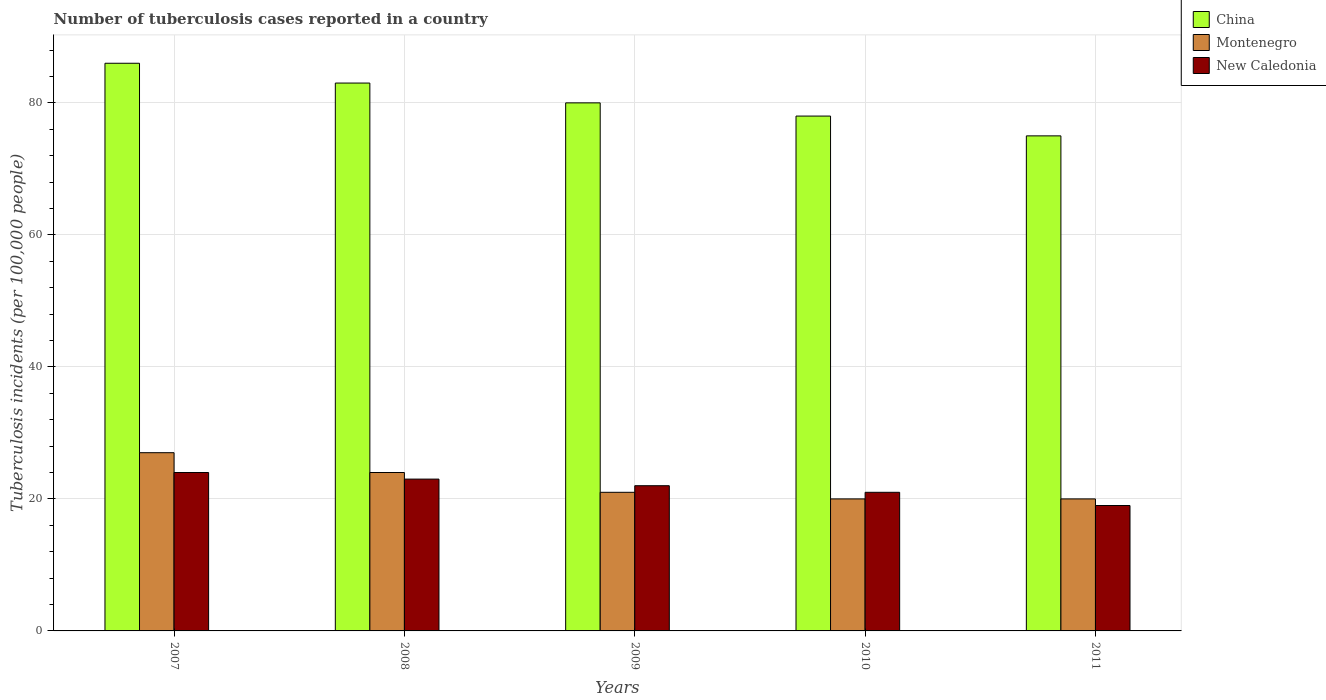How many different coloured bars are there?
Offer a terse response. 3. How many groups of bars are there?
Offer a terse response. 5. Are the number of bars per tick equal to the number of legend labels?
Keep it short and to the point. Yes. How many bars are there on the 4th tick from the left?
Your answer should be compact. 3. What is the number of tuberculosis cases reported in in China in 2007?
Your answer should be compact. 86. Across all years, what is the minimum number of tuberculosis cases reported in in New Caledonia?
Give a very brief answer. 19. In which year was the number of tuberculosis cases reported in in Montenegro maximum?
Make the answer very short. 2007. In which year was the number of tuberculosis cases reported in in New Caledonia minimum?
Offer a terse response. 2011. What is the total number of tuberculosis cases reported in in New Caledonia in the graph?
Provide a short and direct response. 109. What is the difference between the number of tuberculosis cases reported in in China in 2008 and that in 2010?
Provide a short and direct response. 5. What is the difference between the number of tuberculosis cases reported in in Montenegro in 2011 and the number of tuberculosis cases reported in in China in 2007?
Your answer should be very brief. -66. What is the average number of tuberculosis cases reported in in China per year?
Offer a very short reply. 80.4. In the year 2010, what is the difference between the number of tuberculosis cases reported in in Montenegro and number of tuberculosis cases reported in in China?
Provide a succinct answer. -58. In how many years, is the number of tuberculosis cases reported in in Montenegro greater than 60?
Ensure brevity in your answer.  0. What is the ratio of the number of tuberculosis cases reported in in Montenegro in 2007 to that in 2008?
Ensure brevity in your answer.  1.12. Is the difference between the number of tuberculosis cases reported in in Montenegro in 2009 and 2010 greater than the difference between the number of tuberculosis cases reported in in China in 2009 and 2010?
Offer a terse response. No. What is the difference between the highest and the lowest number of tuberculosis cases reported in in China?
Offer a terse response. 11. In how many years, is the number of tuberculosis cases reported in in New Caledonia greater than the average number of tuberculosis cases reported in in New Caledonia taken over all years?
Provide a succinct answer. 3. Is the sum of the number of tuberculosis cases reported in in China in 2007 and 2010 greater than the maximum number of tuberculosis cases reported in in Montenegro across all years?
Your answer should be compact. Yes. What does the 3rd bar from the left in 2009 represents?
Ensure brevity in your answer.  New Caledonia. What does the 2nd bar from the right in 2010 represents?
Offer a terse response. Montenegro. How many bars are there?
Keep it short and to the point. 15. Are all the bars in the graph horizontal?
Your answer should be compact. No. How many years are there in the graph?
Give a very brief answer. 5. Does the graph contain grids?
Give a very brief answer. Yes. What is the title of the graph?
Provide a short and direct response. Number of tuberculosis cases reported in a country. Does "Philippines" appear as one of the legend labels in the graph?
Make the answer very short. No. What is the label or title of the Y-axis?
Make the answer very short. Tuberculosis incidents (per 100,0 people). What is the Tuberculosis incidents (per 100,000 people) in China in 2007?
Keep it short and to the point. 86. What is the Tuberculosis incidents (per 100,000 people) in New Caledonia in 2007?
Keep it short and to the point. 24. What is the Tuberculosis incidents (per 100,000 people) of China in 2008?
Your response must be concise. 83. What is the Tuberculosis incidents (per 100,000 people) of Montenegro in 2008?
Provide a short and direct response. 24. What is the Tuberculosis incidents (per 100,000 people) of New Caledonia in 2008?
Make the answer very short. 23. What is the Tuberculosis incidents (per 100,000 people) in China in 2009?
Offer a very short reply. 80. What is the Tuberculosis incidents (per 100,000 people) of New Caledonia in 2010?
Provide a short and direct response. 21. What is the Tuberculosis incidents (per 100,000 people) in China in 2011?
Provide a succinct answer. 75. Across all years, what is the maximum Tuberculosis incidents (per 100,000 people) of China?
Your answer should be very brief. 86. Across all years, what is the maximum Tuberculosis incidents (per 100,000 people) of Montenegro?
Make the answer very short. 27. Across all years, what is the maximum Tuberculosis incidents (per 100,000 people) of New Caledonia?
Give a very brief answer. 24. Across all years, what is the minimum Tuberculosis incidents (per 100,000 people) of Montenegro?
Your answer should be compact. 20. Across all years, what is the minimum Tuberculosis incidents (per 100,000 people) in New Caledonia?
Make the answer very short. 19. What is the total Tuberculosis incidents (per 100,000 people) in China in the graph?
Give a very brief answer. 402. What is the total Tuberculosis incidents (per 100,000 people) in Montenegro in the graph?
Your response must be concise. 112. What is the total Tuberculosis incidents (per 100,000 people) in New Caledonia in the graph?
Your response must be concise. 109. What is the difference between the Tuberculosis incidents (per 100,000 people) in New Caledonia in 2007 and that in 2009?
Your response must be concise. 2. What is the difference between the Tuberculosis incidents (per 100,000 people) of China in 2007 and that in 2010?
Provide a short and direct response. 8. What is the difference between the Tuberculosis incidents (per 100,000 people) in Montenegro in 2007 and that in 2010?
Offer a very short reply. 7. What is the difference between the Tuberculosis incidents (per 100,000 people) of New Caledonia in 2007 and that in 2010?
Your answer should be compact. 3. What is the difference between the Tuberculosis incidents (per 100,000 people) of Montenegro in 2007 and that in 2011?
Your answer should be very brief. 7. What is the difference between the Tuberculosis incidents (per 100,000 people) of New Caledonia in 2007 and that in 2011?
Give a very brief answer. 5. What is the difference between the Tuberculosis incidents (per 100,000 people) of Montenegro in 2008 and that in 2009?
Ensure brevity in your answer.  3. What is the difference between the Tuberculosis incidents (per 100,000 people) of New Caledonia in 2008 and that in 2009?
Your answer should be very brief. 1. What is the difference between the Tuberculosis incidents (per 100,000 people) in New Caledonia in 2008 and that in 2010?
Give a very brief answer. 2. What is the difference between the Tuberculosis incidents (per 100,000 people) of China in 2008 and that in 2011?
Offer a terse response. 8. What is the difference between the Tuberculosis incidents (per 100,000 people) of Montenegro in 2008 and that in 2011?
Give a very brief answer. 4. What is the difference between the Tuberculosis incidents (per 100,000 people) of New Caledonia in 2008 and that in 2011?
Offer a very short reply. 4. What is the difference between the Tuberculosis incidents (per 100,000 people) of New Caledonia in 2009 and that in 2010?
Offer a terse response. 1. What is the difference between the Tuberculosis incidents (per 100,000 people) of Montenegro in 2010 and that in 2011?
Your answer should be compact. 0. What is the difference between the Tuberculosis incidents (per 100,000 people) in China in 2007 and the Tuberculosis incidents (per 100,000 people) in Montenegro in 2008?
Offer a terse response. 62. What is the difference between the Tuberculosis incidents (per 100,000 people) of Montenegro in 2007 and the Tuberculosis incidents (per 100,000 people) of New Caledonia in 2008?
Your answer should be very brief. 4. What is the difference between the Tuberculosis incidents (per 100,000 people) in China in 2007 and the Tuberculosis incidents (per 100,000 people) in Montenegro in 2009?
Make the answer very short. 65. What is the difference between the Tuberculosis incidents (per 100,000 people) in China in 2007 and the Tuberculosis incidents (per 100,000 people) in New Caledonia in 2009?
Provide a succinct answer. 64. What is the difference between the Tuberculosis incidents (per 100,000 people) of China in 2007 and the Tuberculosis incidents (per 100,000 people) of New Caledonia in 2010?
Make the answer very short. 65. What is the difference between the Tuberculosis incidents (per 100,000 people) of China in 2008 and the Tuberculosis incidents (per 100,000 people) of New Caledonia in 2009?
Make the answer very short. 61. What is the difference between the Tuberculosis incidents (per 100,000 people) of Montenegro in 2008 and the Tuberculosis incidents (per 100,000 people) of New Caledonia in 2009?
Provide a short and direct response. 2. What is the difference between the Tuberculosis incidents (per 100,000 people) in China in 2008 and the Tuberculosis incidents (per 100,000 people) in Montenegro in 2010?
Your response must be concise. 63. What is the difference between the Tuberculosis incidents (per 100,000 people) in China in 2009 and the Tuberculosis incidents (per 100,000 people) in Montenegro in 2010?
Offer a terse response. 60. What is the difference between the Tuberculosis incidents (per 100,000 people) in China in 2009 and the Tuberculosis incidents (per 100,000 people) in New Caledonia in 2010?
Your answer should be very brief. 59. What is the difference between the Tuberculosis incidents (per 100,000 people) of China in 2010 and the Tuberculosis incidents (per 100,000 people) of Montenegro in 2011?
Give a very brief answer. 58. What is the difference between the Tuberculosis incidents (per 100,000 people) of China in 2010 and the Tuberculosis incidents (per 100,000 people) of New Caledonia in 2011?
Your answer should be very brief. 59. What is the difference between the Tuberculosis incidents (per 100,000 people) of Montenegro in 2010 and the Tuberculosis incidents (per 100,000 people) of New Caledonia in 2011?
Ensure brevity in your answer.  1. What is the average Tuberculosis incidents (per 100,000 people) of China per year?
Provide a succinct answer. 80.4. What is the average Tuberculosis incidents (per 100,000 people) in Montenegro per year?
Provide a short and direct response. 22.4. What is the average Tuberculosis incidents (per 100,000 people) of New Caledonia per year?
Your response must be concise. 21.8. In the year 2007, what is the difference between the Tuberculosis incidents (per 100,000 people) in China and Tuberculosis incidents (per 100,000 people) in Montenegro?
Provide a short and direct response. 59. In the year 2007, what is the difference between the Tuberculosis incidents (per 100,000 people) in Montenegro and Tuberculosis incidents (per 100,000 people) in New Caledonia?
Offer a very short reply. 3. In the year 2008, what is the difference between the Tuberculosis incidents (per 100,000 people) in China and Tuberculosis incidents (per 100,000 people) in Montenegro?
Offer a very short reply. 59. In the year 2008, what is the difference between the Tuberculosis incidents (per 100,000 people) in China and Tuberculosis incidents (per 100,000 people) in New Caledonia?
Give a very brief answer. 60. In the year 2009, what is the difference between the Tuberculosis incidents (per 100,000 people) in China and Tuberculosis incidents (per 100,000 people) in Montenegro?
Offer a very short reply. 59. In the year 2010, what is the difference between the Tuberculosis incidents (per 100,000 people) in China and Tuberculosis incidents (per 100,000 people) in New Caledonia?
Make the answer very short. 57. In the year 2010, what is the difference between the Tuberculosis incidents (per 100,000 people) of Montenegro and Tuberculosis incidents (per 100,000 people) of New Caledonia?
Your response must be concise. -1. In the year 2011, what is the difference between the Tuberculosis incidents (per 100,000 people) of China and Tuberculosis incidents (per 100,000 people) of Montenegro?
Provide a short and direct response. 55. In the year 2011, what is the difference between the Tuberculosis incidents (per 100,000 people) in China and Tuberculosis incidents (per 100,000 people) in New Caledonia?
Offer a very short reply. 56. In the year 2011, what is the difference between the Tuberculosis incidents (per 100,000 people) in Montenegro and Tuberculosis incidents (per 100,000 people) in New Caledonia?
Provide a short and direct response. 1. What is the ratio of the Tuberculosis incidents (per 100,000 people) of China in 2007 to that in 2008?
Ensure brevity in your answer.  1.04. What is the ratio of the Tuberculosis incidents (per 100,000 people) in Montenegro in 2007 to that in 2008?
Offer a terse response. 1.12. What is the ratio of the Tuberculosis incidents (per 100,000 people) in New Caledonia in 2007 to that in 2008?
Provide a short and direct response. 1.04. What is the ratio of the Tuberculosis incidents (per 100,000 people) in China in 2007 to that in 2009?
Provide a short and direct response. 1.07. What is the ratio of the Tuberculosis incidents (per 100,000 people) in China in 2007 to that in 2010?
Your answer should be very brief. 1.1. What is the ratio of the Tuberculosis incidents (per 100,000 people) of Montenegro in 2007 to that in 2010?
Your response must be concise. 1.35. What is the ratio of the Tuberculosis incidents (per 100,000 people) of China in 2007 to that in 2011?
Make the answer very short. 1.15. What is the ratio of the Tuberculosis incidents (per 100,000 people) in Montenegro in 2007 to that in 2011?
Ensure brevity in your answer.  1.35. What is the ratio of the Tuberculosis incidents (per 100,000 people) of New Caledonia in 2007 to that in 2011?
Provide a succinct answer. 1.26. What is the ratio of the Tuberculosis incidents (per 100,000 people) in China in 2008 to that in 2009?
Give a very brief answer. 1.04. What is the ratio of the Tuberculosis incidents (per 100,000 people) of Montenegro in 2008 to that in 2009?
Provide a short and direct response. 1.14. What is the ratio of the Tuberculosis incidents (per 100,000 people) of New Caledonia in 2008 to that in 2009?
Ensure brevity in your answer.  1.05. What is the ratio of the Tuberculosis incidents (per 100,000 people) in China in 2008 to that in 2010?
Provide a succinct answer. 1.06. What is the ratio of the Tuberculosis incidents (per 100,000 people) in Montenegro in 2008 to that in 2010?
Offer a very short reply. 1.2. What is the ratio of the Tuberculosis incidents (per 100,000 people) of New Caledonia in 2008 to that in 2010?
Give a very brief answer. 1.1. What is the ratio of the Tuberculosis incidents (per 100,000 people) in China in 2008 to that in 2011?
Offer a very short reply. 1.11. What is the ratio of the Tuberculosis incidents (per 100,000 people) in Montenegro in 2008 to that in 2011?
Ensure brevity in your answer.  1.2. What is the ratio of the Tuberculosis incidents (per 100,000 people) of New Caledonia in 2008 to that in 2011?
Ensure brevity in your answer.  1.21. What is the ratio of the Tuberculosis incidents (per 100,000 people) in China in 2009 to that in 2010?
Provide a succinct answer. 1.03. What is the ratio of the Tuberculosis incidents (per 100,000 people) of Montenegro in 2009 to that in 2010?
Provide a short and direct response. 1.05. What is the ratio of the Tuberculosis incidents (per 100,000 people) in New Caledonia in 2009 to that in 2010?
Offer a terse response. 1.05. What is the ratio of the Tuberculosis incidents (per 100,000 people) of China in 2009 to that in 2011?
Offer a terse response. 1.07. What is the ratio of the Tuberculosis incidents (per 100,000 people) in New Caledonia in 2009 to that in 2011?
Provide a succinct answer. 1.16. What is the ratio of the Tuberculosis incidents (per 100,000 people) in Montenegro in 2010 to that in 2011?
Keep it short and to the point. 1. What is the ratio of the Tuberculosis incidents (per 100,000 people) of New Caledonia in 2010 to that in 2011?
Ensure brevity in your answer.  1.11. What is the difference between the highest and the second highest Tuberculosis incidents (per 100,000 people) of New Caledonia?
Offer a terse response. 1. What is the difference between the highest and the lowest Tuberculosis incidents (per 100,000 people) of China?
Ensure brevity in your answer.  11. What is the difference between the highest and the lowest Tuberculosis incidents (per 100,000 people) of New Caledonia?
Offer a terse response. 5. 